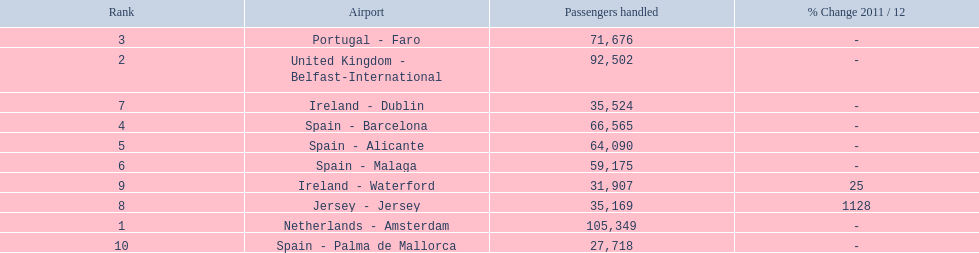How many passengers did the united kingdom handle? 92,502. Who handled more passengers than this? Netherlands - Amsterdam. 